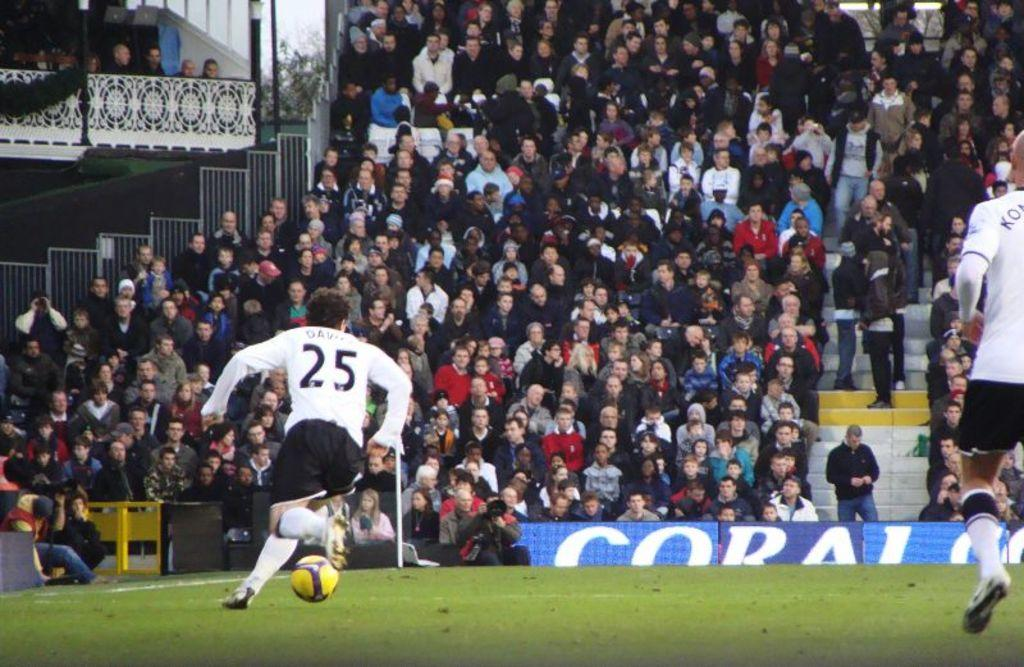<image>
Write a terse but informative summary of the picture. A soccer player with the number 25 on his back starts to kick the ball. 